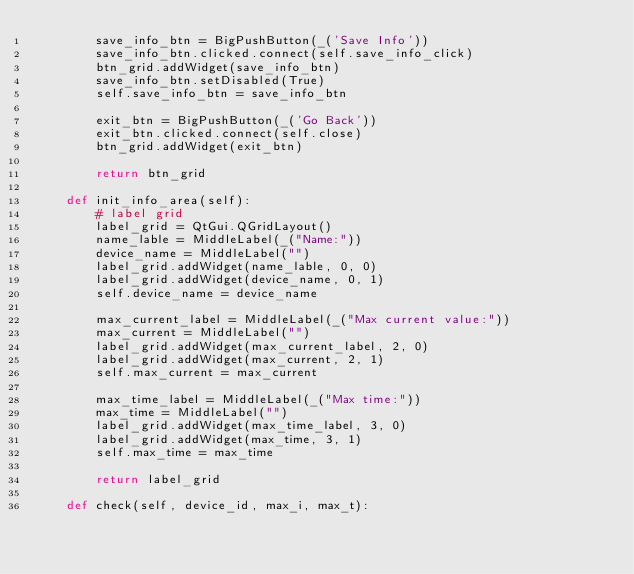<code> <loc_0><loc_0><loc_500><loc_500><_Python_>        save_info_btn = BigPushButton(_('Save Info'))
        save_info_btn.clicked.connect(self.save_info_click)
        btn_grid.addWidget(save_info_btn)
        save_info_btn.setDisabled(True)
        self.save_info_btn = save_info_btn

        exit_btn = BigPushButton(_('Go Back'))
        exit_btn.clicked.connect(self.close)
        btn_grid.addWidget(exit_btn)

        return btn_grid

    def init_info_area(self):
        # label grid
        label_grid = QtGui.QGridLayout()
        name_lable = MiddleLabel(_("Name:"))
        device_name = MiddleLabel("")
        label_grid.addWidget(name_lable, 0, 0)
        label_grid.addWidget(device_name, 0, 1)
        self.device_name = device_name

        max_current_label = MiddleLabel(_("Max current value:"))
        max_current = MiddleLabel("")
        label_grid.addWidget(max_current_label, 2, 0)
        label_grid.addWidget(max_current, 2, 1)
        self.max_current = max_current

        max_time_label = MiddleLabel(_("Max time:"))
        max_time = MiddleLabel("")
        label_grid.addWidget(max_time_label, 3, 0)
        label_grid.addWidget(max_time, 3, 1)
        self.max_time = max_time

        return label_grid

    def check(self, device_id, max_i, max_t):</code> 